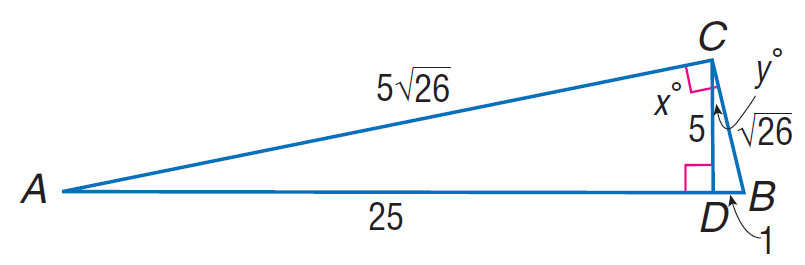Answer the mathemtical geometry problem and directly provide the correct option letter.
Question: Find \cos A.
Choices: A: \frac { \sqrt { 26 } } { 26 } B: \frac { 2 \sqrt { 26 } } { 26 } C: \frac { 5 \sqrt { 26 } } { 26 } D: \frac { 7 \sqrt { 26 } } { 26 } C 